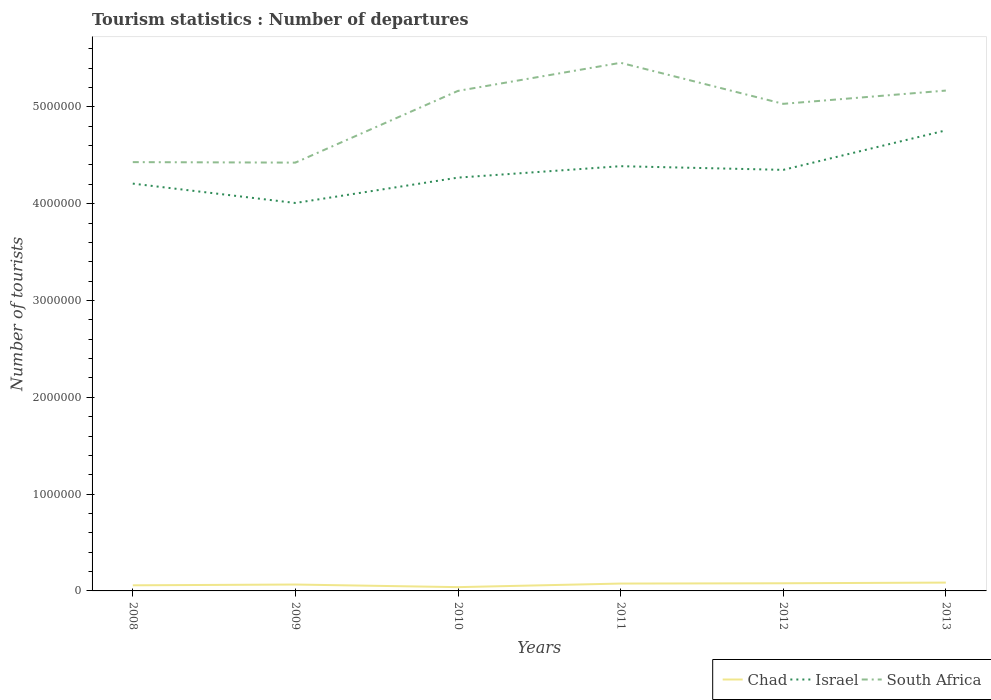Is the number of lines equal to the number of legend labels?
Provide a succinct answer. Yes. Across all years, what is the maximum number of tourist departures in South Africa?
Offer a terse response. 4.42e+06. In which year was the number of tourist departures in Israel maximum?
Give a very brief answer. 2009. What is the total number of tourist departures in South Africa in the graph?
Make the answer very short. 1.34e+05. What is the difference between the highest and the second highest number of tourist departures in Chad?
Provide a short and direct response. 4.70e+04. How many years are there in the graph?
Give a very brief answer. 6. What is the title of the graph?
Give a very brief answer. Tourism statistics : Number of departures. What is the label or title of the X-axis?
Offer a very short reply. Years. What is the label or title of the Y-axis?
Your response must be concise. Number of tourists. What is the Number of tourists of Chad in 2008?
Your answer should be very brief. 5.80e+04. What is the Number of tourists of Israel in 2008?
Offer a terse response. 4.21e+06. What is the Number of tourists in South Africa in 2008?
Provide a short and direct response. 4.43e+06. What is the Number of tourists in Chad in 2009?
Give a very brief answer. 6.60e+04. What is the Number of tourists in Israel in 2009?
Provide a succinct answer. 4.01e+06. What is the Number of tourists in South Africa in 2009?
Keep it short and to the point. 4.42e+06. What is the Number of tourists in Chad in 2010?
Your answer should be very brief. 3.90e+04. What is the Number of tourists of Israel in 2010?
Make the answer very short. 4.27e+06. What is the Number of tourists in South Africa in 2010?
Your response must be concise. 5.16e+06. What is the Number of tourists of Chad in 2011?
Offer a terse response. 7.60e+04. What is the Number of tourists in Israel in 2011?
Your response must be concise. 4.39e+06. What is the Number of tourists in South Africa in 2011?
Provide a short and direct response. 5.46e+06. What is the Number of tourists in Chad in 2012?
Ensure brevity in your answer.  7.90e+04. What is the Number of tourists of Israel in 2012?
Your answer should be very brief. 4.35e+06. What is the Number of tourists in South Africa in 2012?
Your answer should be compact. 5.03e+06. What is the Number of tourists in Chad in 2013?
Your response must be concise. 8.60e+04. What is the Number of tourists of Israel in 2013?
Offer a terse response. 4.76e+06. What is the Number of tourists in South Africa in 2013?
Offer a very short reply. 5.17e+06. Across all years, what is the maximum Number of tourists of Chad?
Offer a very short reply. 8.60e+04. Across all years, what is the maximum Number of tourists of Israel?
Your answer should be compact. 4.76e+06. Across all years, what is the maximum Number of tourists of South Africa?
Offer a terse response. 5.46e+06. Across all years, what is the minimum Number of tourists in Chad?
Provide a succinct answer. 3.90e+04. Across all years, what is the minimum Number of tourists of Israel?
Provide a short and direct response. 4.01e+06. Across all years, what is the minimum Number of tourists in South Africa?
Your response must be concise. 4.42e+06. What is the total Number of tourists of Chad in the graph?
Provide a succinct answer. 4.04e+05. What is the total Number of tourists in Israel in the graph?
Give a very brief answer. 2.60e+07. What is the total Number of tourists of South Africa in the graph?
Your answer should be very brief. 2.97e+07. What is the difference between the Number of tourists in Chad in 2008 and that in 2009?
Provide a succinct answer. -8000. What is the difference between the Number of tourists in South Africa in 2008 and that in 2009?
Provide a short and direct response. 5000. What is the difference between the Number of tourists in Chad in 2008 and that in 2010?
Keep it short and to the point. 1.90e+04. What is the difference between the Number of tourists in Israel in 2008 and that in 2010?
Offer a terse response. -6.20e+04. What is the difference between the Number of tourists in South Africa in 2008 and that in 2010?
Provide a succinct answer. -7.36e+05. What is the difference between the Number of tourists in Chad in 2008 and that in 2011?
Your answer should be very brief. -1.80e+04. What is the difference between the Number of tourists of South Africa in 2008 and that in 2011?
Offer a very short reply. -1.03e+06. What is the difference between the Number of tourists in Chad in 2008 and that in 2012?
Your response must be concise. -2.10e+04. What is the difference between the Number of tourists in Israel in 2008 and that in 2012?
Offer a very short reply. -1.42e+05. What is the difference between the Number of tourists in South Africa in 2008 and that in 2012?
Give a very brief answer. -6.02e+05. What is the difference between the Number of tourists in Chad in 2008 and that in 2013?
Ensure brevity in your answer.  -2.80e+04. What is the difference between the Number of tourists in Israel in 2008 and that in 2013?
Your answer should be compact. -5.50e+05. What is the difference between the Number of tourists in South Africa in 2008 and that in 2013?
Your answer should be compact. -7.39e+05. What is the difference between the Number of tourists of Chad in 2009 and that in 2010?
Make the answer very short. 2.70e+04. What is the difference between the Number of tourists of Israel in 2009 and that in 2010?
Provide a short and direct response. -2.62e+05. What is the difference between the Number of tourists in South Africa in 2009 and that in 2010?
Offer a very short reply. -7.41e+05. What is the difference between the Number of tourists in Israel in 2009 and that in 2011?
Make the answer very short. -3.80e+05. What is the difference between the Number of tourists in South Africa in 2009 and that in 2011?
Give a very brief answer. -1.03e+06. What is the difference between the Number of tourists in Chad in 2009 and that in 2012?
Provide a succinct answer. -1.30e+04. What is the difference between the Number of tourists of Israel in 2009 and that in 2012?
Offer a very short reply. -3.42e+05. What is the difference between the Number of tourists in South Africa in 2009 and that in 2012?
Keep it short and to the point. -6.07e+05. What is the difference between the Number of tourists in Chad in 2009 and that in 2013?
Your answer should be compact. -2.00e+04. What is the difference between the Number of tourists in Israel in 2009 and that in 2013?
Keep it short and to the point. -7.50e+05. What is the difference between the Number of tourists in South Africa in 2009 and that in 2013?
Provide a short and direct response. -7.44e+05. What is the difference between the Number of tourists in Chad in 2010 and that in 2011?
Give a very brief answer. -3.70e+04. What is the difference between the Number of tourists in Israel in 2010 and that in 2011?
Give a very brief answer. -1.18e+05. What is the difference between the Number of tourists in Chad in 2010 and that in 2012?
Give a very brief answer. -4.00e+04. What is the difference between the Number of tourists of Israel in 2010 and that in 2012?
Ensure brevity in your answer.  -8.00e+04. What is the difference between the Number of tourists of South Africa in 2010 and that in 2012?
Ensure brevity in your answer.  1.34e+05. What is the difference between the Number of tourists in Chad in 2010 and that in 2013?
Provide a short and direct response. -4.70e+04. What is the difference between the Number of tourists of Israel in 2010 and that in 2013?
Your response must be concise. -4.88e+05. What is the difference between the Number of tourists of South Africa in 2010 and that in 2013?
Offer a very short reply. -3000. What is the difference between the Number of tourists of Chad in 2011 and that in 2012?
Offer a terse response. -3000. What is the difference between the Number of tourists of Israel in 2011 and that in 2012?
Make the answer very short. 3.80e+04. What is the difference between the Number of tourists of South Africa in 2011 and that in 2012?
Keep it short and to the point. 4.24e+05. What is the difference between the Number of tourists of Israel in 2011 and that in 2013?
Give a very brief answer. -3.70e+05. What is the difference between the Number of tourists in South Africa in 2011 and that in 2013?
Make the answer very short. 2.87e+05. What is the difference between the Number of tourists in Chad in 2012 and that in 2013?
Provide a short and direct response. -7000. What is the difference between the Number of tourists of Israel in 2012 and that in 2013?
Your response must be concise. -4.08e+05. What is the difference between the Number of tourists in South Africa in 2012 and that in 2013?
Ensure brevity in your answer.  -1.37e+05. What is the difference between the Number of tourists in Chad in 2008 and the Number of tourists in Israel in 2009?
Your answer should be very brief. -3.95e+06. What is the difference between the Number of tourists of Chad in 2008 and the Number of tourists of South Africa in 2009?
Ensure brevity in your answer.  -4.37e+06. What is the difference between the Number of tourists in Israel in 2008 and the Number of tourists in South Africa in 2009?
Your answer should be compact. -2.17e+05. What is the difference between the Number of tourists of Chad in 2008 and the Number of tourists of Israel in 2010?
Your answer should be very brief. -4.21e+06. What is the difference between the Number of tourists of Chad in 2008 and the Number of tourists of South Africa in 2010?
Your answer should be compact. -5.11e+06. What is the difference between the Number of tourists of Israel in 2008 and the Number of tourists of South Africa in 2010?
Keep it short and to the point. -9.58e+05. What is the difference between the Number of tourists of Chad in 2008 and the Number of tourists of Israel in 2011?
Give a very brief answer. -4.33e+06. What is the difference between the Number of tourists of Chad in 2008 and the Number of tourists of South Africa in 2011?
Your answer should be very brief. -5.40e+06. What is the difference between the Number of tourists in Israel in 2008 and the Number of tourists in South Africa in 2011?
Your answer should be compact. -1.25e+06. What is the difference between the Number of tourists in Chad in 2008 and the Number of tourists in Israel in 2012?
Provide a short and direct response. -4.29e+06. What is the difference between the Number of tourists in Chad in 2008 and the Number of tourists in South Africa in 2012?
Offer a very short reply. -4.97e+06. What is the difference between the Number of tourists of Israel in 2008 and the Number of tourists of South Africa in 2012?
Give a very brief answer. -8.24e+05. What is the difference between the Number of tourists in Chad in 2008 and the Number of tourists in Israel in 2013?
Make the answer very short. -4.70e+06. What is the difference between the Number of tourists in Chad in 2008 and the Number of tourists in South Africa in 2013?
Keep it short and to the point. -5.11e+06. What is the difference between the Number of tourists in Israel in 2008 and the Number of tourists in South Africa in 2013?
Provide a succinct answer. -9.61e+05. What is the difference between the Number of tourists of Chad in 2009 and the Number of tourists of Israel in 2010?
Give a very brief answer. -4.20e+06. What is the difference between the Number of tourists of Chad in 2009 and the Number of tourists of South Africa in 2010?
Offer a very short reply. -5.10e+06. What is the difference between the Number of tourists in Israel in 2009 and the Number of tourists in South Africa in 2010?
Give a very brief answer. -1.16e+06. What is the difference between the Number of tourists of Chad in 2009 and the Number of tourists of Israel in 2011?
Your answer should be very brief. -4.32e+06. What is the difference between the Number of tourists of Chad in 2009 and the Number of tourists of South Africa in 2011?
Your response must be concise. -5.39e+06. What is the difference between the Number of tourists in Israel in 2009 and the Number of tourists in South Africa in 2011?
Offer a very short reply. -1.45e+06. What is the difference between the Number of tourists of Chad in 2009 and the Number of tourists of Israel in 2012?
Offer a terse response. -4.28e+06. What is the difference between the Number of tourists of Chad in 2009 and the Number of tourists of South Africa in 2012?
Provide a succinct answer. -4.96e+06. What is the difference between the Number of tourists in Israel in 2009 and the Number of tourists in South Africa in 2012?
Provide a short and direct response. -1.02e+06. What is the difference between the Number of tourists of Chad in 2009 and the Number of tourists of Israel in 2013?
Provide a short and direct response. -4.69e+06. What is the difference between the Number of tourists in Chad in 2009 and the Number of tourists in South Africa in 2013?
Give a very brief answer. -5.10e+06. What is the difference between the Number of tourists in Israel in 2009 and the Number of tourists in South Africa in 2013?
Give a very brief answer. -1.16e+06. What is the difference between the Number of tourists in Chad in 2010 and the Number of tourists in Israel in 2011?
Your response must be concise. -4.35e+06. What is the difference between the Number of tourists of Chad in 2010 and the Number of tourists of South Africa in 2011?
Provide a short and direct response. -5.42e+06. What is the difference between the Number of tourists in Israel in 2010 and the Number of tourists in South Africa in 2011?
Your answer should be compact. -1.19e+06. What is the difference between the Number of tourists in Chad in 2010 and the Number of tourists in Israel in 2012?
Make the answer very short. -4.31e+06. What is the difference between the Number of tourists of Chad in 2010 and the Number of tourists of South Africa in 2012?
Make the answer very short. -4.99e+06. What is the difference between the Number of tourists in Israel in 2010 and the Number of tourists in South Africa in 2012?
Give a very brief answer. -7.62e+05. What is the difference between the Number of tourists in Chad in 2010 and the Number of tourists in Israel in 2013?
Offer a very short reply. -4.72e+06. What is the difference between the Number of tourists of Chad in 2010 and the Number of tourists of South Africa in 2013?
Your response must be concise. -5.13e+06. What is the difference between the Number of tourists in Israel in 2010 and the Number of tourists in South Africa in 2013?
Provide a succinct answer. -8.99e+05. What is the difference between the Number of tourists in Chad in 2011 and the Number of tourists in Israel in 2012?
Your answer should be compact. -4.27e+06. What is the difference between the Number of tourists of Chad in 2011 and the Number of tourists of South Africa in 2012?
Offer a terse response. -4.96e+06. What is the difference between the Number of tourists of Israel in 2011 and the Number of tourists of South Africa in 2012?
Your answer should be very brief. -6.44e+05. What is the difference between the Number of tourists in Chad in 2011 and the Number of tourists in Israel in 2013?
Provide a succinct answer. -4.68e+06. What is the difference between the Number of tourists in Chad in 2011 and the Number of tourists in South Africa in 2013?
Keep it short and to the point. -5.09e+06. What is the difference between the Number of tourists in Israel in 2011 and the Number of tourists in South Africa in 2013?
Provide a short and direct response. -7.81e+05. What is the difference between the Number of tourists in Chad in 2012 and the Number of tourists in Israel in 2013?
Offer a very short reply. -4.68e+06. What is the difference between the Number of tourists of Chad in 2012 and the Number of tourists of South Africa in 2013?
Your answer should be compact. -5.09e+06. What is the difference between the Number of tourists of Israel in 2012 and the Number of tourists of South Africa in 2013?
Provide a succinct answer. -8.19e+05. What is the average Number of tourists of Chad per year?
Provide a short and direct response. 6.73e+04. What is the average Number of tourists of Israel per year?
Your answer should be very brief. 4.33e+06. What is the average Number of tourists of South Africa per year?
Give a very brief answer. 4.95e+06. In the year 2008, what is the difference between the Number of tourists of Chad and Number of tourists of Israel?
Offer a terse response. -4.15e+06. In the year 2008, what is the difference between the Number of tourists of Chad and Number of tourists of South Africa?
Your response must be concise. -4.37e+06. In the year 2008, what is the difference between the Number of tourists of Israel and Number of tourists of South Africa?
Your answer should be very brief. -2.22e+05. In the year 2009, what is the difference between the Number of tourists of Chad and Number of tourists of Israel?
Ensure brevity in your answer.  -3.94e+06. In the year 2009, what is the difference between the Number of tourists in Chad and Number of tourists in South Africa?
Provide a short and direct response. -4.36e+06. In the year 2009, what is the difference between the Number of tourists of Israel and Number of tourists of South Africa?
Ensure brevity in your answer.  -4.17e+05. In the year 2010, what is the difference between the Number of tourists of Chad and Number of tourists of Israel?
Your answer should be compact. -4.23e+06. In the year 2010, what is the difference between the Number of tourists of Chad and Number of tourists of South Africa?
Keep it short and to the point. -5.13e+06. In the year 2010, what is the difference between the Number of tourists of Israel and Number of tourists of South Africa?
Provide a succinct answer. -8.96e+05. In the year 2011, what is the difference between the Number of tourists in Chad and Number of tourists in Israel?
Ensure brevity in your answer.  -4.31e+06. In the year 2011, what is the difference between the Number of tourists of Chad and Number of tourists of South Africa?
Give a very brief answer. -5.38e+06. In the year 2011, what is the difference between the Number of tourists in Israel and Number of tourists in South Africa?
Offer a terse response. -1.07e+06. In the year 2012, what is the difference between the Number of tourists of Chad and Number of tourists of Israel?
Offer a terse response. -4.27e+06. In the year 2012, what is the difference between the Number of tourists in Chad and Number of tourists in South Africa?
Give a very brief answer. -4.95e+06. In the year 2012, what is the difference between the Number of tourists of Israel and Number of tourists of South Africa?
Offer a terse response. -6.82e+05. In the year 2013, what is the difference between the Number of tourists of Chad and Number of tourists of Israel?
Ensure brevity in your answer.  -4.67e+06. In the year 2013, what is the difference between the Number of tourists of Chad and Number of tourists of South Africa?
Provide a succinct answer. -5.08e+06. In the year 2013, what is the difference between the Number of tourists of Israel and Number of tourists of South Africa?
Offer a terse response. -4.11e+05. What is the ratio of the Number of tourists of Chad in 2008 to that in 2009?
Make the answer very short. 0.88. What is the ratio of the Number of tourists in Israel in 2008 to that in 2009?
Your response must be concise. 1.05. What is the ratio of the Number of tourists in Chad in 2008 to that in 2010?
Offer a very short reply. 1.49. What is the ratio of the Number of tourists in Israel in 2008 to that in 2010?
Offer a terse response. 0.99. What is the ratio of the Number of tourists of South Africa in 2008 to that in 2010?
Give a very brief answer. 0.86. What is the ratio of the Number of tourists in Chad in 2008 to that in 2011?
Ensure brevity in your answer.  0.76. What is the ratio of the Number of tourists of Israel in 2008 to that in 2011?
Offer a terse response. 0.96. What is the ratio of the Number of tourists of South Africa in 2008 to that in 2011?
Make the answer very short. 0.81. What is the ratio of the Number of tourists of Chad in 2008 to that in 2012?
Offer a terse response. 0.73. What is the ratio of the Number of tourists of Israel in 2008 to that in 2012?
Make the answer very short. 0.97. What is the ratio of the Number of tourists of South Africa in 2008 to that in 2012?
Your answer should be compact. 0.88. What is the ratio of the Number of tourists of Chad in 2008 to that in 2013?
Offer a very short reply. 0.67. What is the ratio of the Number of tourists in Israel in 2008 to that in 2013?
Ensure brevity in your answer.  0.88. What is the ratio of the Number of tourists of South Africa in 2008 to that in 2013?
Give a very brief answer. 0.86. What is the ratio of the Number of tourists of Chad in 2009 to that in 2010?
Offer a terse response. 1.69. What is the ratio of the Number of tourists in Israel in 2009 to that in 2010?
Keep it short and to the point. 0.94. What is the ratio of the Number of tourists of South Africa in 2009 to that in 2010?
Your answer should be very brief. 0.86. What is the ratio of the Number of tourists in Chad in 2009 to that in 2011?
Offer a very short reply. 0.87. What is the ratio of the Number of tourists of Israel in 2009 to that in 2011?
Ensure brevity in your answer.  0.91. What is the ratio of the Number of tourists of South Africa in 2009 to that in 2011?
Keep it short and to the point. 0.81. What is the ratio of the Number of tourists of Chad in 2009 to that in 2012?
Ensure brevity in your answer.  0.84. What is the ratio of the Number of tourists of Israel in 2009 to that in 2012?
Your answer should be very brief. 0.92. What is the ratio of the Number of tourists in South Africa in 2009 to that in 2012?
Keep it short and to the point. 0.88. What is the ratio of the Number of tourists of Chad in 2009 to that in 2013?
Make the answer very short. 0.77. What is the ratio of the Number of tourists of Israel in 2009 to that in 2013?
Offer a very short reply. 0.84. What is the ratio of the Number of tourists in South Africa in 2009 to that in 2013?
Provide a succinct answer. 0.86. What is the ratio of the Number of tourists of Chad in 2010 to that in 2011?
Your answer should be compact. 0.51. What is the ratio of the Number of tourists in Israel in 2010 to that in 2011?
Your answer should be compact. 0.97. What is the ratio of the Number of tourists in South Africa in 2010 to that in 2011?
Provide a succinct answer. 0.95. What is the ratio of the Number of tourists of Chad in 2010 to that in 2012?
Your response must be concise. 0.49. What is the ratio of the Number of tourists in Israel in 2010 to that in 2012?
Make the answer very short. 0.98. What is the ratio of the Number of tourists in South Africa in 2010 to that in 2012?
Offer a terse response. 1.03. What is the ratio of the Number of tourists of Chad in 2010 to that in 2013?
Provide a short and direct response. 0.45. What is the ratio of the Number of tourists of Israel in 2010 to that in 2013?
Offer a very short reply. 0.9. What is the ratio of the Number of tourists of South Africa in 2010 to that in 2013?
Your answer should be compact. 1. What is the ratio of the Number of tourists in Chad in 2011 to that in 2012?
Offer a very short reply. 0.96. What is the ratio of the Number of tourists in Israel in 2011 to that in 2012?
Give a very brief answer. 1.01. What is the ratio of the Number of tourists of South Africa in 2011 to that in 2012?
Give a very brief answer. 1.08. What is the ratio of the Number of tourists of Chad in 2011 to that in 2013?
Ensure brevity in your answer.  0.88. What is the ratio of the Number of tourists in Israel in 2011 to that in 2013?
Make the answer very short. 0.92. What is the ratio of the Number of tourists in South Africa in 2011 to that in 2013?
Give a very brief answer. 1.06. What is the ratio of the Number of tourists in Chad in 2012 to that in 2013?
Provide a succinct answer. 0.92. What is the ratio of the Number of tourists of Israel in 2012 to that in 2013?
Provide a short and direct response. 0.91. What is the ratio of the Number of tourists of South Africa in 2012 to that in 2013?
Provide a short and direct response. 0.97. What is the difference between the highest and the second highest Number of tourists in Chad?
Give a very brief answer. 7000. What is the difference between the highest and the second highest Number of tourists of Israel?
Offer a very short reply. 3.70e+05. What is the difference between the highest and the second highest Number of tourists in South Africa?
Offer a very short reply. 2.87e+05. What is the difference between the highest and the lowest Number of tourists of Chad?
Provide a short and direct response. 4.70e+04. What is the difference between the highest and the lowest Number of tourists of Israel?
Provide a succinct answer. 7.50e+05. What is the difference between the highest and the lowest Number of tourists of South Africa?
Provide a succinct answer. 1.03e+06. 